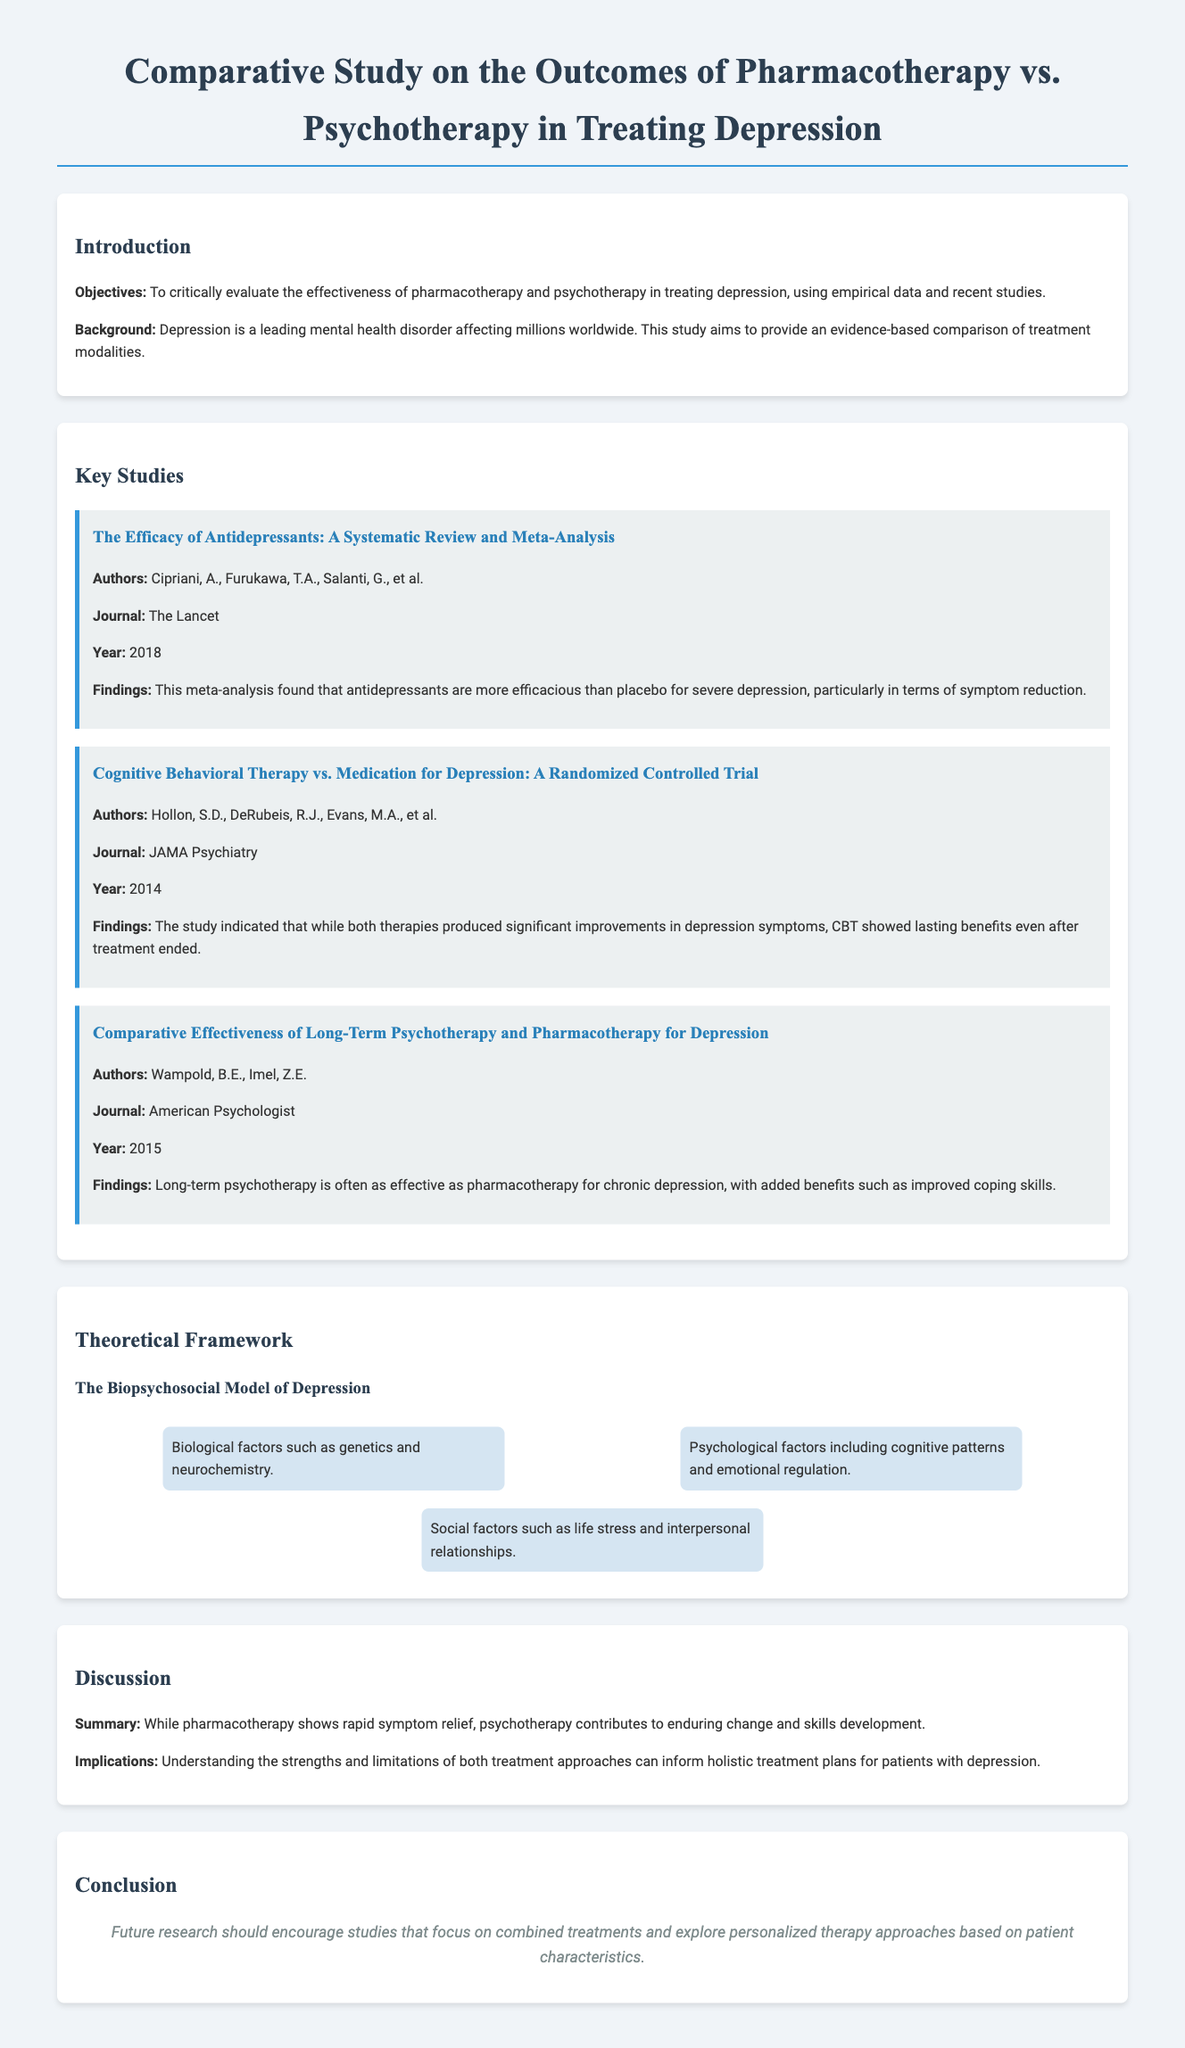What is the main objective of the study? The main objective of the study is to critically evaluate the effectiveness of pharmacotherapy and psychotherapy in treating depression.
Answer: To critically evaluate the effectiveness of pharmacotherapy and psychotherapy in treating depression Who are the authors of the study titled "The Efficacy of Antidepressants"? The authors of this study include Cipriani, A., Furukawa, T.A., Salanti, G., et al.
Answer: Cipriani, A., Furukawa, T.A., Salanti, G., et al In which journal was the study on Cognitive Behavioral Therapy published? The study on Cognitive Behavioral Therapy was published in JAMA Psychiatry.
Answer: JAMA Psychiatry What year was the comparative effectiveness study published? The comparative effectiveness study was published in 2015.
Answer: 2015 What therapy showed lasting benefits after treatment ended? Cognitive Behavioral Therapy showed lasting benefits after treatment ended.
Answer: Cognitive Behavioral Therapy According to the document, what model is used to explain depression? The document indicates the use of the Biopsychosocial Model of Depression.
Answer: Biopsychosocial Model of Depression What are the three factors in the Biopsychosocial Model? The three factors are biological, psychological, and social.
Answer: Biological, psychological, and social What do the implications of the discussion suggest? The implications suggest understanding strengths and limitations of both treatment approaches for holistic treatment plans.
Answer: Understanding strengths and limitations of both treatment approaches 